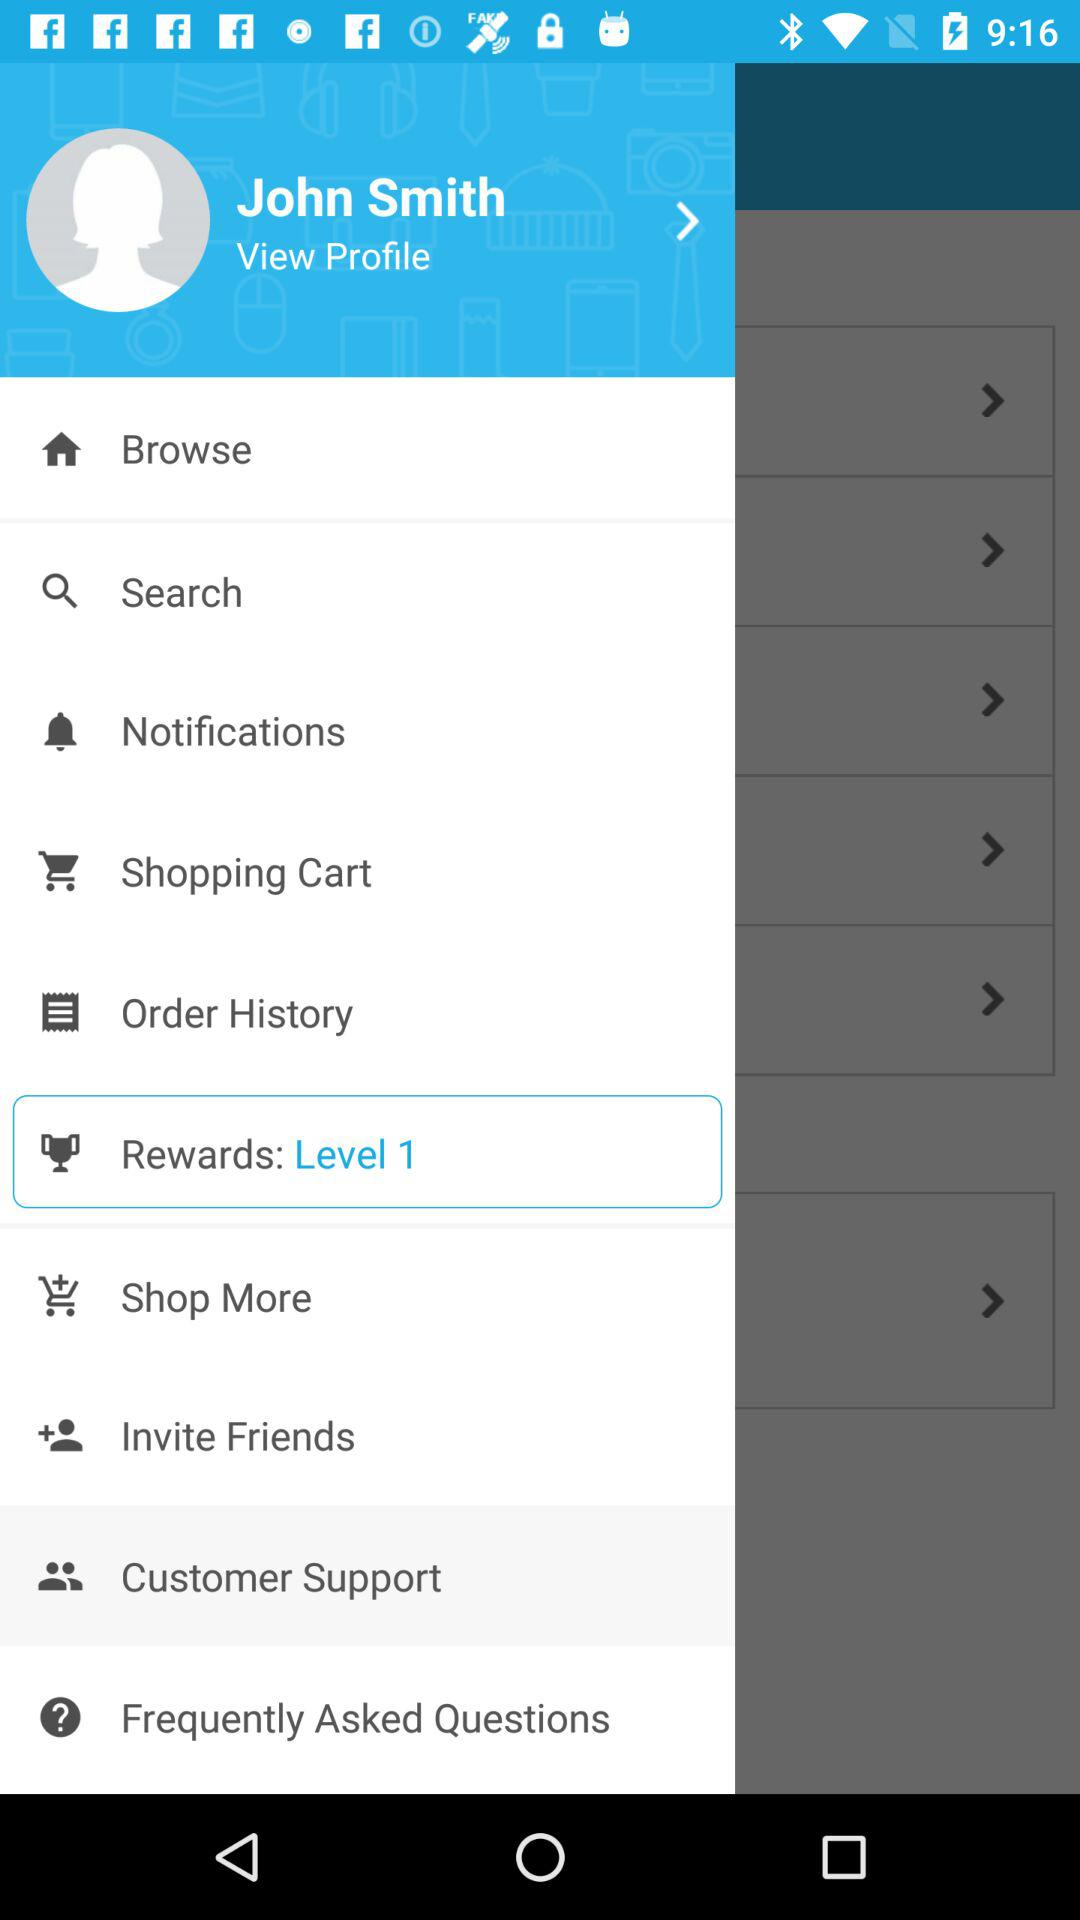What is the user name? The user name is "John Smith". 